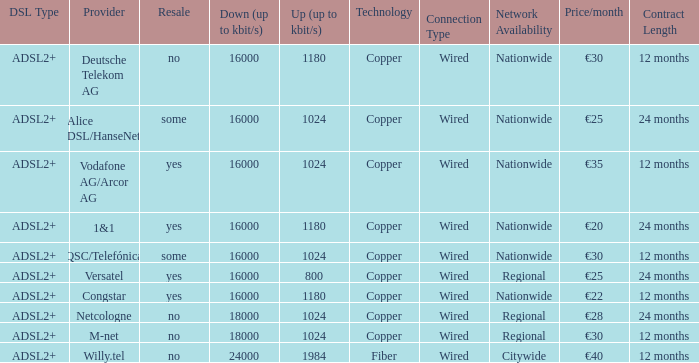How many providers are there where the resale category is yes and bandwith is up is 1024? 1.0. 